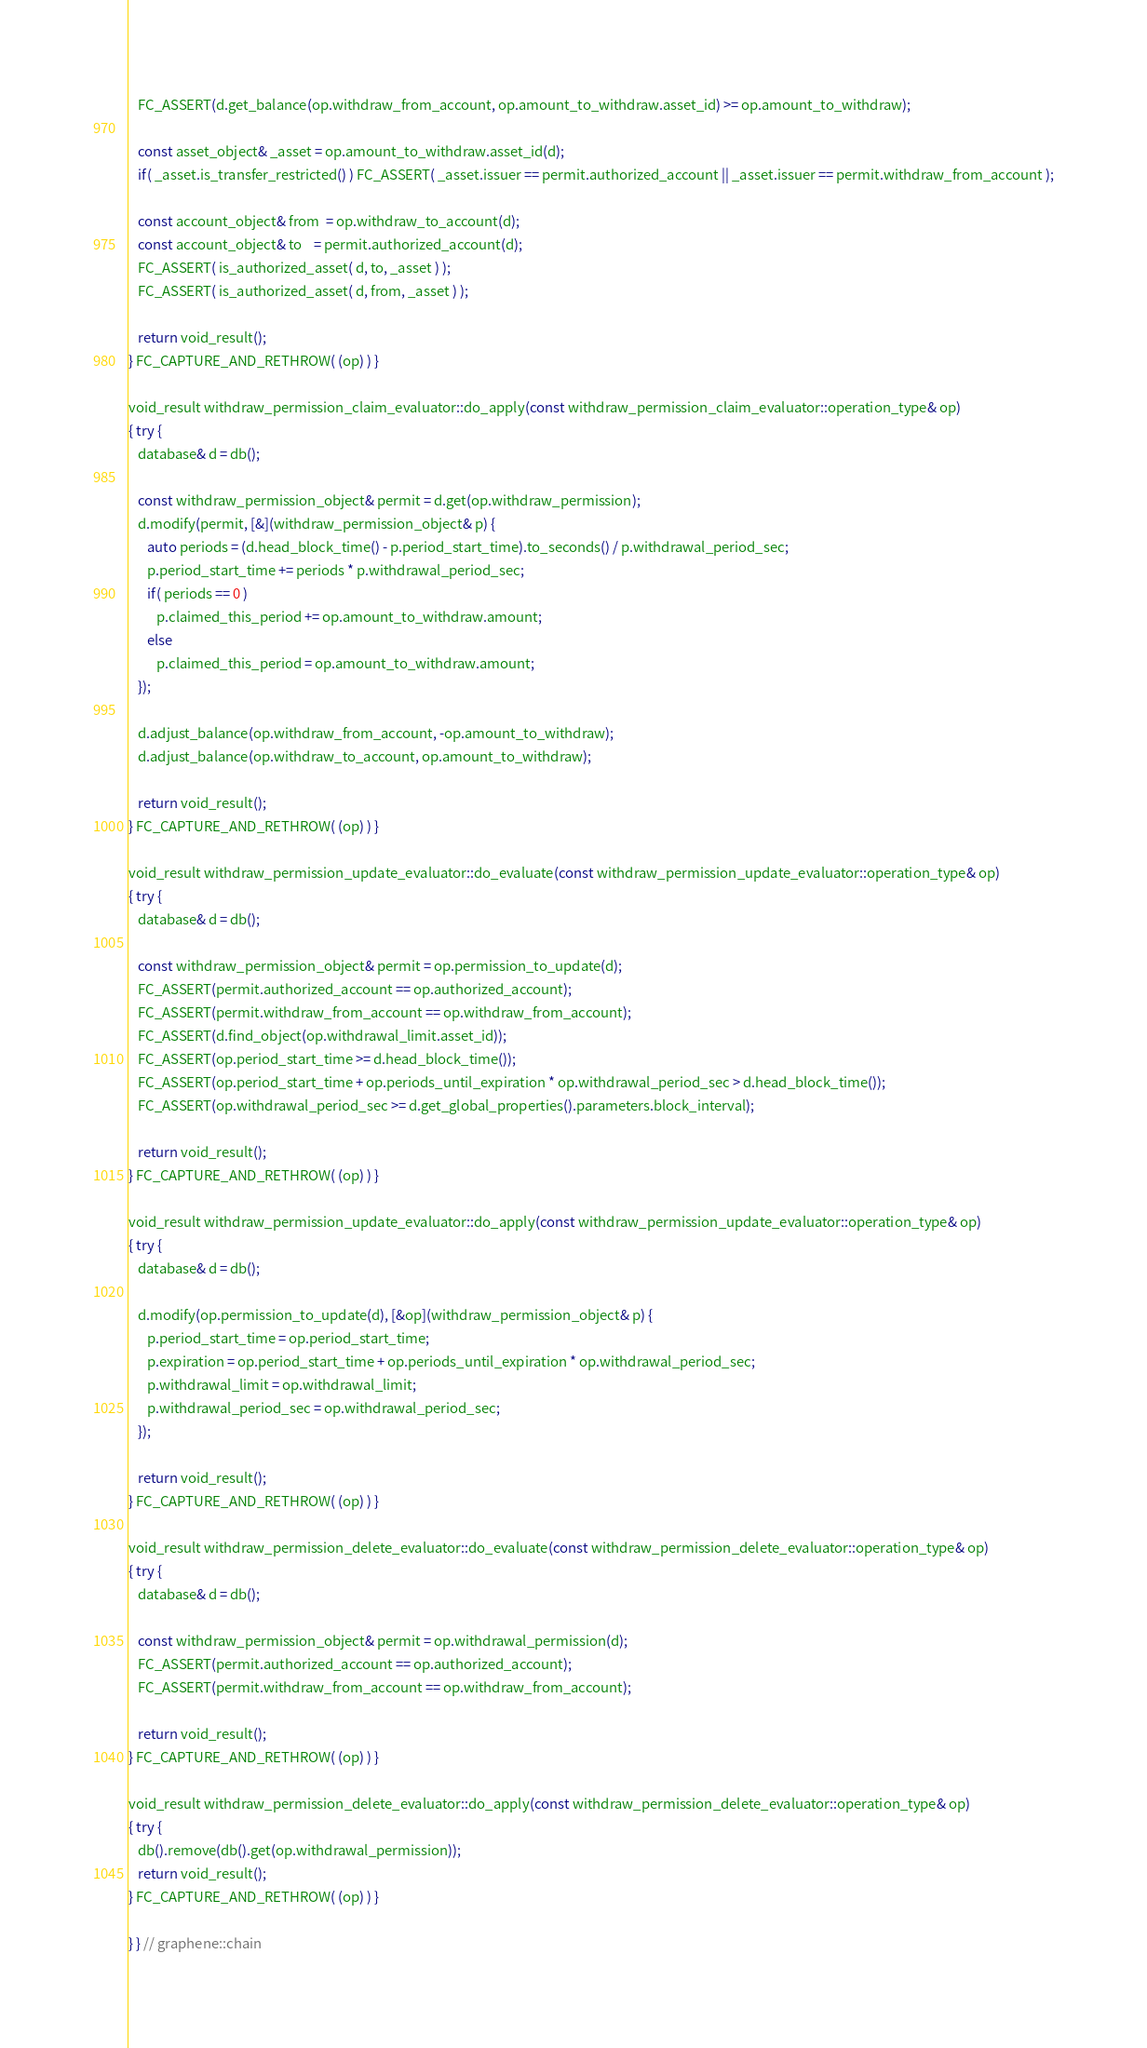Convert code to text. <code><loc_0><loc_0><loc_500><loc_500><_C++_>   FC_ASSERT(d.get_balance(op.withdraw_from_account, op.amount_to_withdraw.asset_id) >= op.amount_to_withdraw);

   const asset_object& _asset = op.amount_to_withdraw.asset_id(d);
   if( _asset.is_transfer_restricted() ) FC_ASSERT( _asset.issuer == permit.authorized_account || _asset.issuer == permit.withdraw_from_account );

   const account_object& from  = op.withdraw_to_account(d);
   const account_object& to    = permit.authorized_account(d);
   FC_ASSERT( is_authorized_asset( d, to, _asset ) );
   FC_ASSERT( is_authorized_asset( d, from, _asset ) );

   return void_result();
} FC_CAPTURE_AND_RETHROW( (op) ) }

void_result withdraw_permission_claim_evaluator::do_apply(const withdraw_permission_claim_evaluator::operation_type& op)
{ try {
   database& d = db();

   const withdraw_permission_object& permit = d.get(op.withdraw_permission);
   d.modify(permit, [&](withdraw_permission_object& p) {
      auto periods = (d.head_block_time() - p.period_start_time).to_seconds() / p.withdrawal_period_sec;
      p.period_start_time += periods * p.withdrawal_period_sec;
      if( periods == 0 )
         p.claimed_this_period += op.amount_to_withdraw.amount;
      else
         p.claimed_this_period = op.amount_to_withdraw.amount;
   });

   d.adjust_balance(op.withdraw_from_account, -op.amount_to_withdraw);
   d.adjust_balance(op.withdraw_to_account, op.amount_to_withdraw);

   return void_result();
} FC_CAPTURE_AND_RETHROW( (op) ) }

void_result withdraw_permission_update_evaluator::do_evaluate(const withdraw_permission_update_evaluator::operation_type& op)
{ try {
   database& d = db();

   const withdraw_permission_object& permit = op.permission_to_update(d);
   FC_ASSERT(permit.authorized_account == op.authorized_account);
   FC_ASSERT(permit.withdraw_from_account == op.withdraw_from_account);
   FC_ASSERT(d.find_object(op.withdrawal_limit.asset_id));
   FC_ASSERT(op.period_start_time >= d.head_block_time());
   FC_ASSERT(op.period_start_time + op.periods_until_expiration * op.withdrawal_period_sec > d.head_block_time());
   FC_ASSERT(op.withdrawal_period_sec >= d.get_global_properties().parameters.block_interval);

   return void_result();
} FC_CAPTURE_AND_RETHROW( (op) ) }

void_result withdraw_permission_update_evaluator::do_apply(const withdraw_permission_update_evaluator::operation_type& op)
{ try {
   database& d = db();

   d.modify(op.permission_to_update(d), [&op](withdraw_permission_object& p) {
      p.period_start_time = op.period_start_time;
      p.expiration = op.period_start_time + op.periods_until_expiration * op.withdrawal_period_sec;
      p.withdrawal_limit = op.withdrawal_limit;
      p.withdrawal_period_sec = op.withdrawal_period_sec;
   });

   return void_result();
} FC_CAPTURE_AND_RETHROW( (op) ) }

void_result withdraw_permission_delete_evaluator::do_evaluate(const withdraw_permission_delete_evaluator::operation_type& op)
{ try {
   database& d = db();

   const withdraw_permission_object& permit = op.withdrawal_permission(d);
   FC_ASSERT(permit.authorized_account == op.authorized_account);
   FC_ASSERT(permit.withdraw_from_account == op.withdraw_from_account);

   return void_result();
} FC_CAPTURE_AND_RETHROW( (op) ) }

void_result withdraw_permission_delete_evaluator::do_apply(const withdraw_permission_delete_evaluator::operation_type& op)
{ try {
   db().remove(db().get(op.withdrawal_permission));
   return void_result();
} FC_CAPTURE_AND_RETHROW( (op) ) }

} } // graphene::chain
</code> 